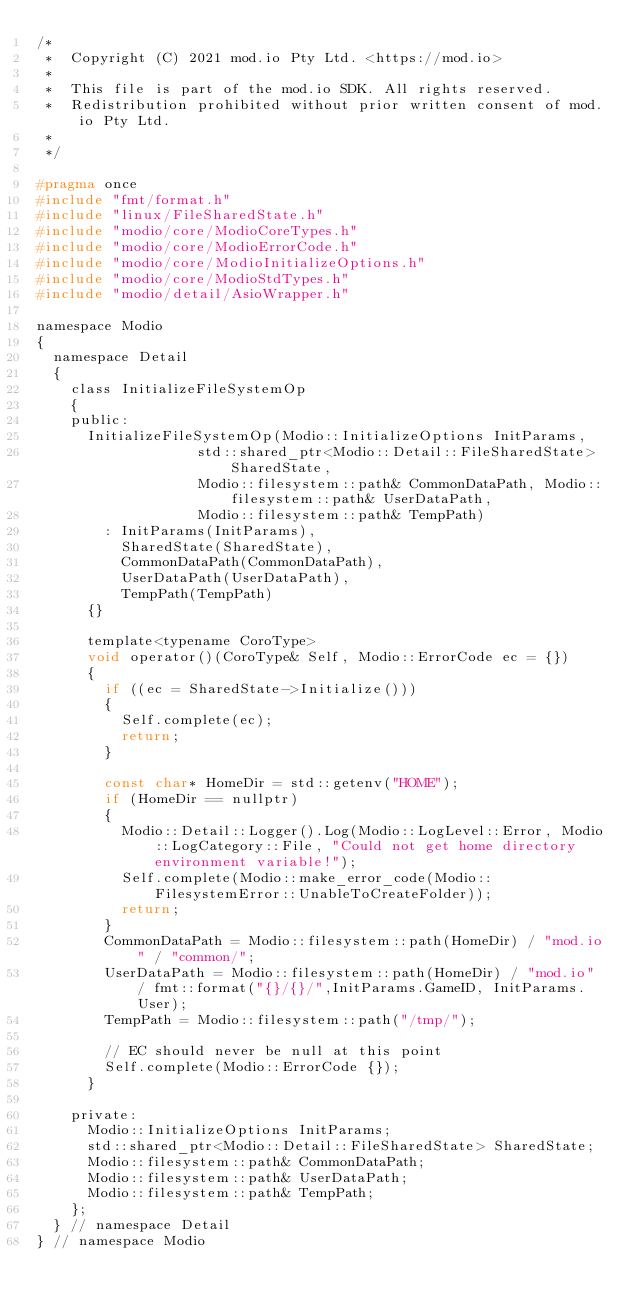<code> <loc_0><loc_0><loc_500><loc_500><_C_>/*
 *  Copyright (C) 2021 mod.io Pty Ltd. <https://mod.io>
 *
 *  This file is part of the mod.io SDK. All rights reserved.
 *  Redistribution prohibited without prior written consent of mod.io Pty Ltd.
 *
 */

#pragma once
#include "fmt/format.h"
#include "linux/FileSharedState.h"
#include "modio/core/ModioCoreTypes.h"
#include "modio/core/ModioErrorCode.h"
#include "modio/core/ModioInitializeOptions.h"
#include "modio/core/ModioStdTypes.h"
#include "modio/detail/AsioWrapper.h"

namespace Modio
{
	namespace Detail
	{
		class InitializeFileSystemOp
		{
		public:
			InitializeFileSystemOp(Modio::InitializeOptions InitParams,
								   std::shared_ptr<Modio::Detail::FileSharedState> SharedState,
								   Modio::filesystem::path& CommonDataPath, Modio::filesystem::path& UserDataPath,
								   Modio::filesystem::path& TempPath)
				: InitParams(InitParams),
				  SharedState(SharedState),
				  CommonDataPath(CommonDataPath),
				  UserDataPath(UserDataPath),
				  TempPath(TempPath)
			{}

			template<typename CoroType>
			void operator()(CoroType& Self, Modio::ErrorCode ec = {})
			{
				if ((ec = SharedState->Initialize()))
				{
					Self.complete(ec);
					return;
				}
				
				const char* HomeDir = std::getenv("HOME");
				if (HomeDir == nullptr)
				{
					Modio::Detail::Logger().Log(Modio::LogLevel::Error, Modio::LogCategory::File, "Could not get home directory environment variable!");
					Self.complete(Modio::make_error_code(Modio::FilesystemError::UnableToCreateFolder));
					return;
				}
				CommonDataPath = Modio::filesystem::path(HomeDir) / "mod.io" / "common/";
				UserDataPath = Modio::filesystem::path(HomeDir) / "mod.io" / fmt::format("{}/{}/",InitParams.GameID, InitParams.User);
				TempPath = Modio::filesystem::path("/tmp/");

				// EC should never be null at this point
				Self.complete(Modio::ErrorCode {});
			}

		private:
			Modio::InitializeOptions InitParams;
			std::shared_ptr<Modio::Detail::FileSharedState> SharedState;
			Modio::filesystem::path& CommonDataPath;
			Modio::filesystem::path& UserDataPath;
			Modio::filesystem::path& TempPath;
		};
	} // namespace Detail
} // namespace Modio</code> 